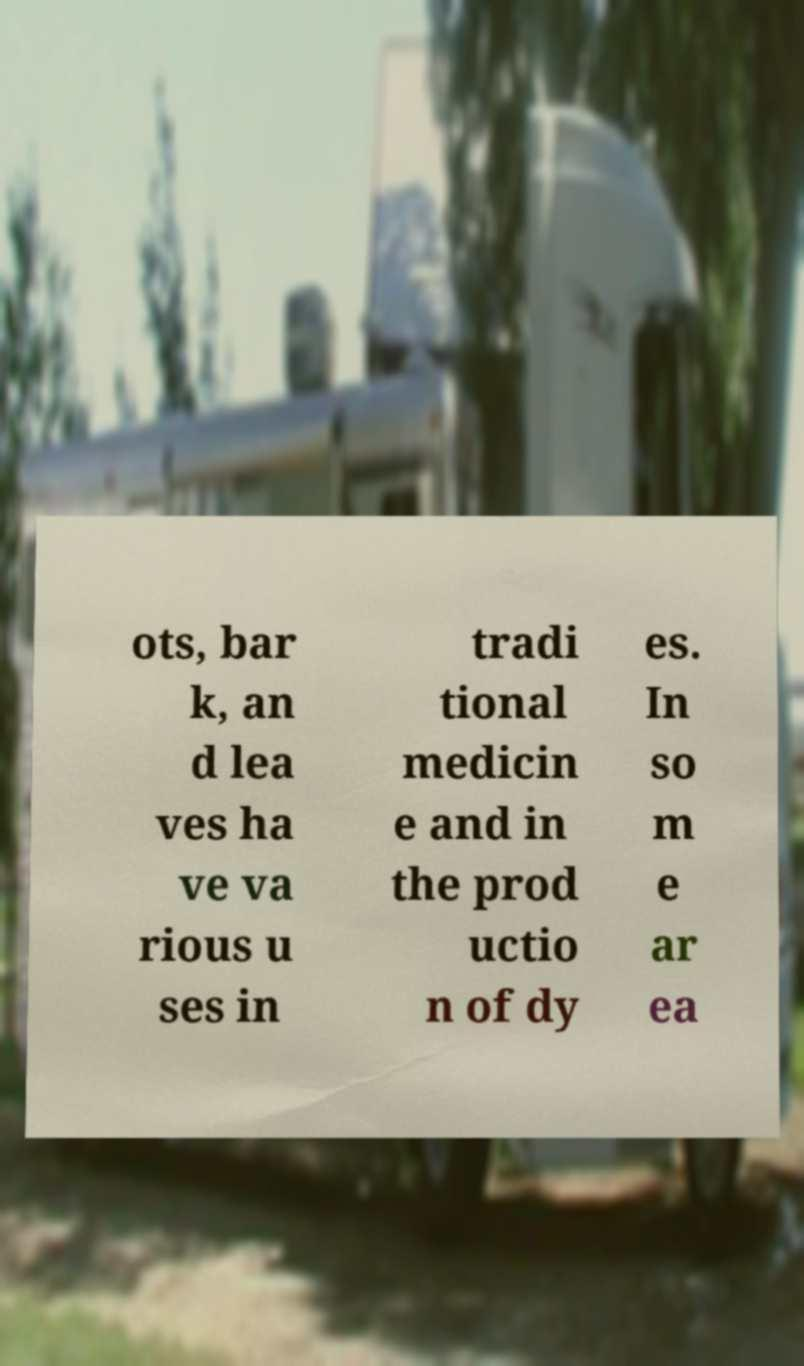Could you extract and type out the text from this image? ots, bar k, an d lea ves ha ve va rious u ses in tradi tional medicin e and in the prod uctio n of dy es. In so m e ar ea 